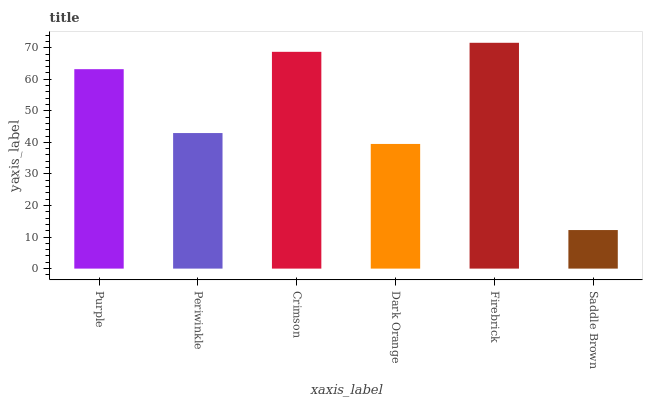Is Saddle Brown the minimum?
Answer yes or no. Yes. Is Firebrick the maximum?
Answer yes or no. Yes. Is Periwinkle the minimum?
Answer yes or no. No. Is Periwinkle the maximum?
Answer yes or no. No. Is Purple greater than Periwinkle?
Answer yes or no. Yes. Is Periwinkle less than Purple?
Answer yes or no. Yes. Is Periwinkle greater than Purple?
Answer yes or no. No. Is Purple less than Periwinkle?
Answer yes or no. No. Is Purple the high median?
Answer yes or no. Yes. Is Periwinkle the low median?
Answer yes or no. Yes. Is Periwinkle the high median?
Answer yes or no. No. Is Saddle Brown the low median?
Answer yes or no. No. 